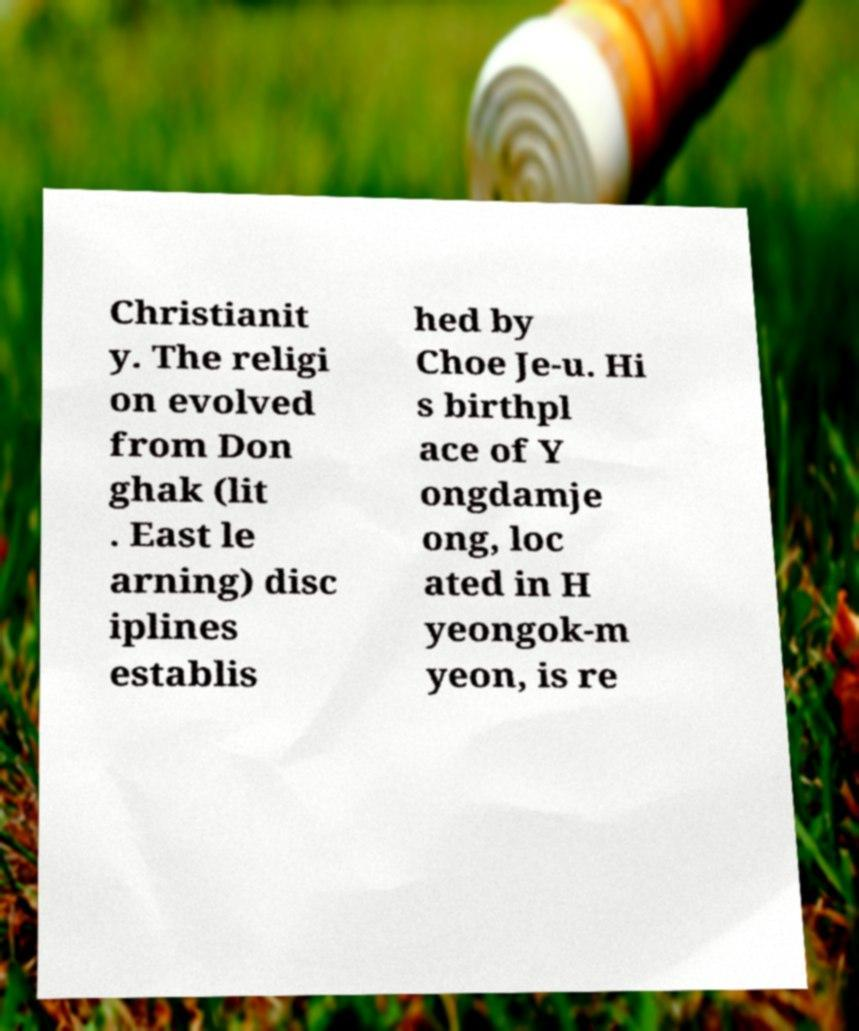Could you assist in decoding the text presented in this image and type it out clearly? Christianit y. The religi on evolved from Don ghak (lit . East le arning) disc iplines establis hed by Choe Je-u. Hi s birthpl ace of Y ongdamje ong, loc ated in H yeongok-m yeon, is re 